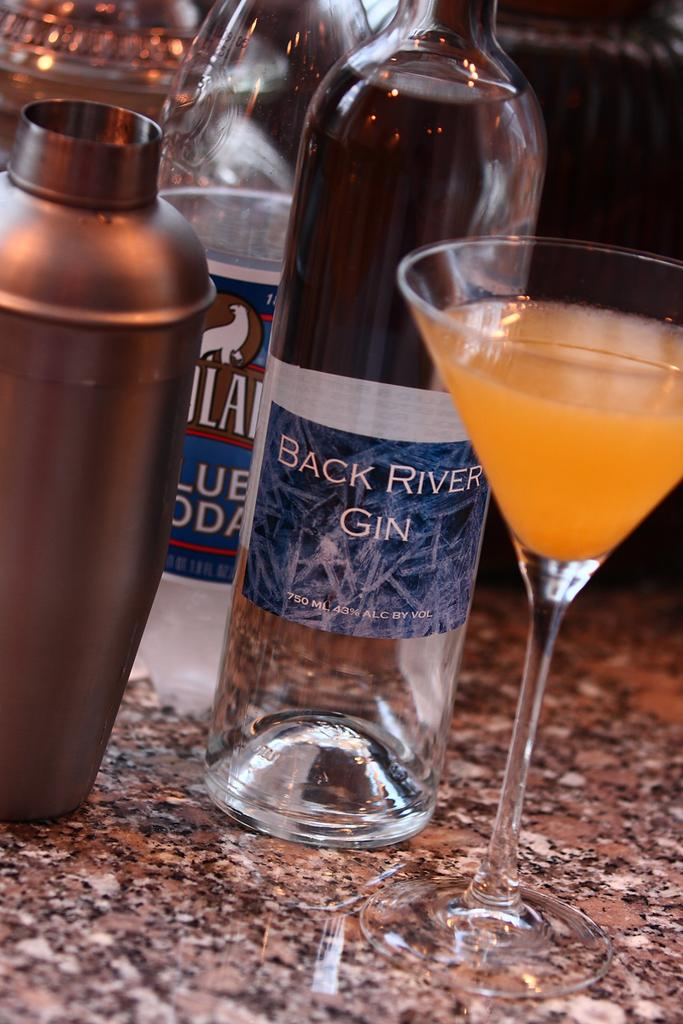<image>
Write a terse but informative summary of the picture. Bottle of Back River Gin next to a cup of alcohol. 